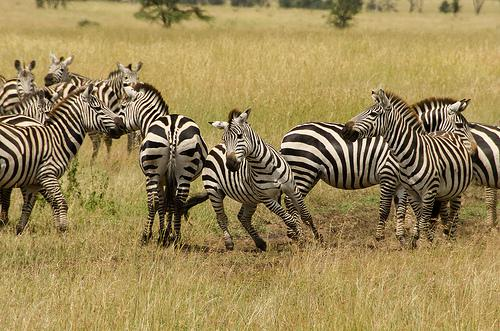Question: how is the photo?
Choices:
A. Dark.
B. Fuzzy.
C. Light.
D. Clear.
Answer with the letter. Answer: D Question: what type of scene?
Choices:
A. Outdoor.
B. Indoor.
C. Bedroom.
D. Bar.
Answer with the letter. Answer: A Question: what animal are they?
Choices:
A. Zebras.
B. Giraffes.
C. Elephants.
D. Lions.
Answer with the letter. Answer: A 